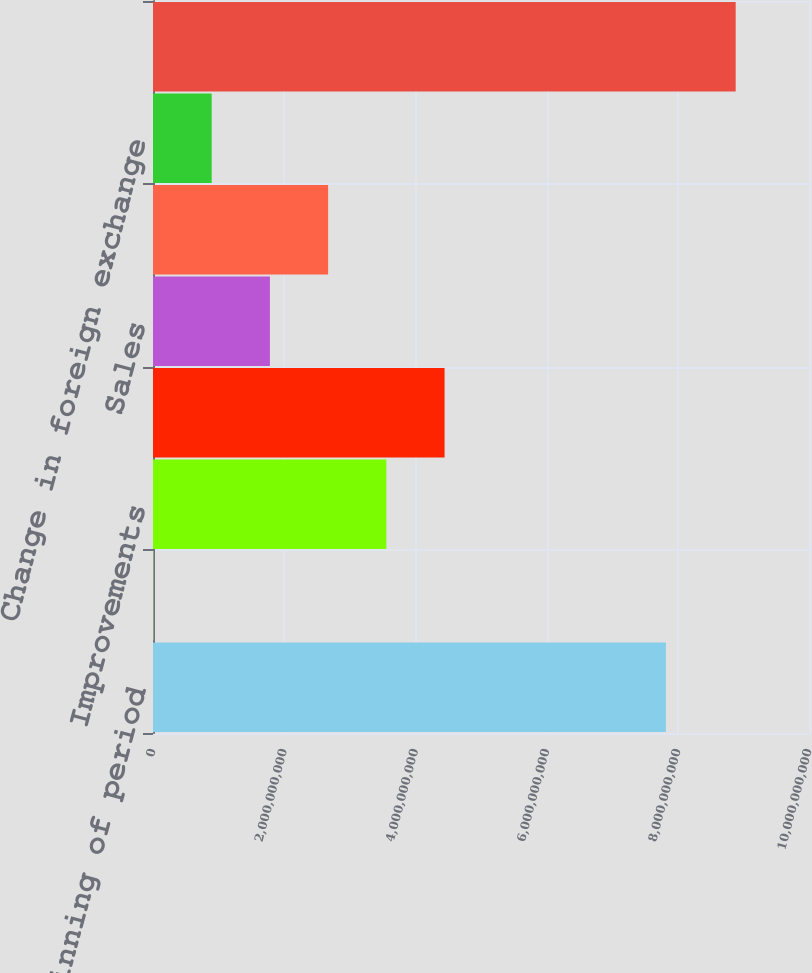<chart> <loc_0><loc_0><loc_500><loc_500><bar_chart><fcel>Balance beginning of period<fcel>Acquisitions<fcel>Improvements<fcel>Transfers from (to)<fcel>Sales<fcel>Adjustment of property<fcel>Change in foreign exchange<fcel>Balance end of period<nl><fcel>7.81892e+09<fcel>7.13624e+06<fcel>3.55722e+09<fcel>4.44474e+09<fcel>1.78218e+09<fcel>2.6697e+09<fcel>8.94657e+08<fcel>8.88234e+09<nl></chart> 